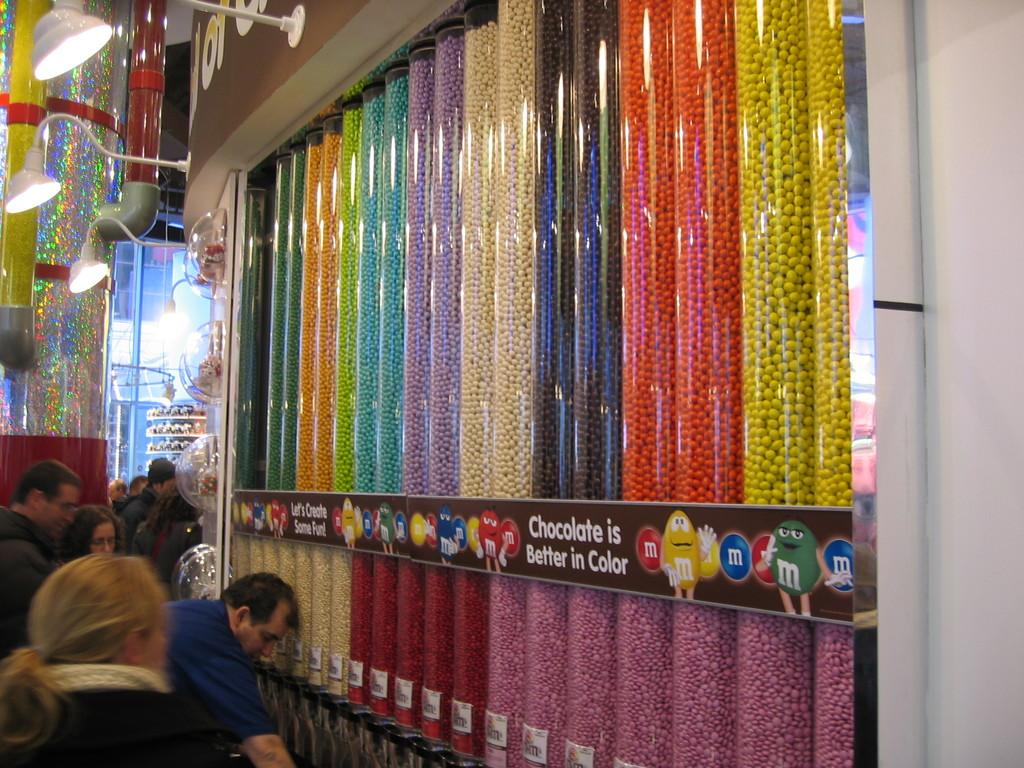<image>
Describe the image concisely. the word chocolate is on the sign above the man 